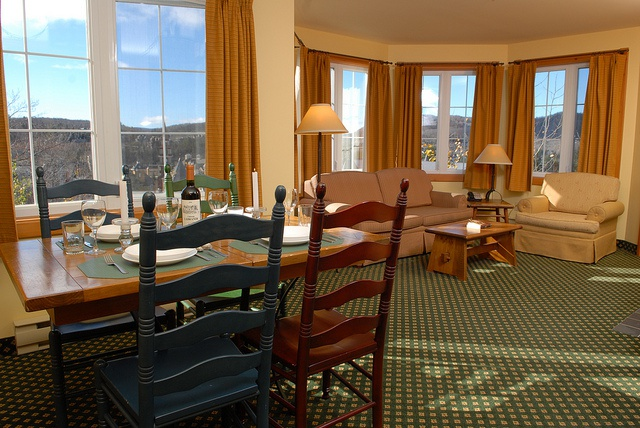Describe the objects in this image and their specific colors. I can see chair in violet, black, gray, brown, and olive tones, chair in violet, black, maroon, olive, and brown tones, dining table in violet, black, darkgray, and gray tones, chair in violet, olive, tan, and maroon tones, and couch in violet, brown, and maroon tones in this image. 